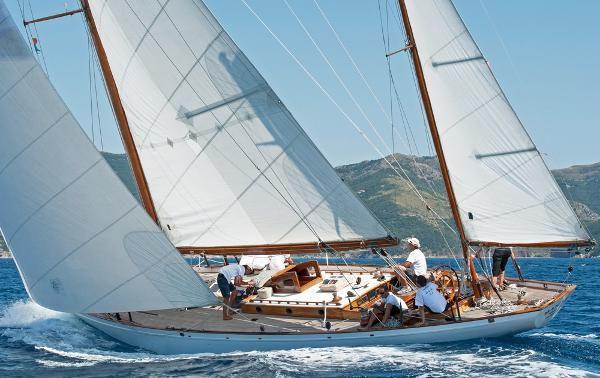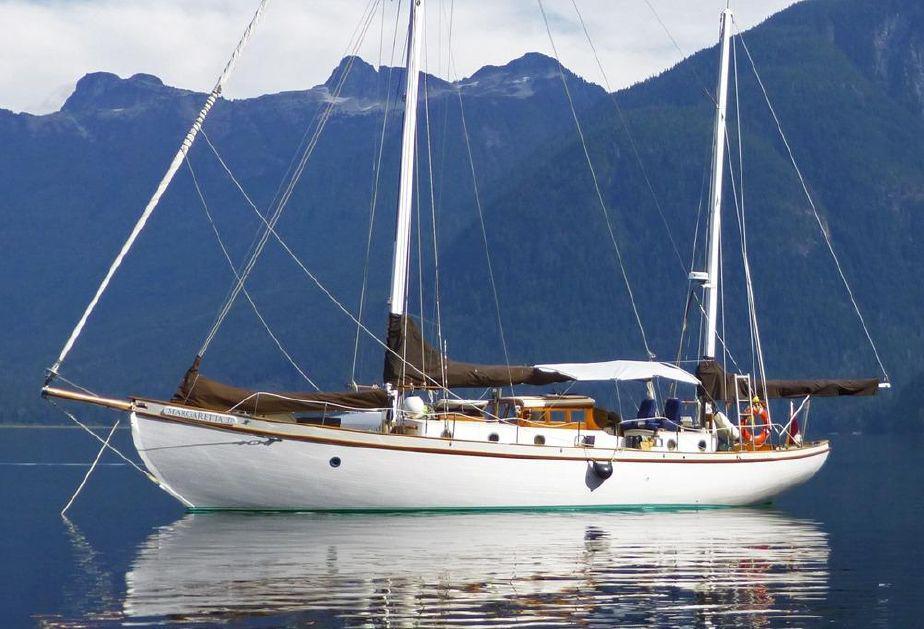The first image is the image on the left, the second image is the image on the right. Considering the images on both sides, is "In at least one image there is a boat with 3 sails raised" valid? Answer yes or no. Yes. The first image is the image on the left, the second image is the image on the right. For the images displayed, is the sentence "One image in the pair shows the boat's sails up, the other image shows the sails folded down." factually correct? Answer yes or no. Yes. 